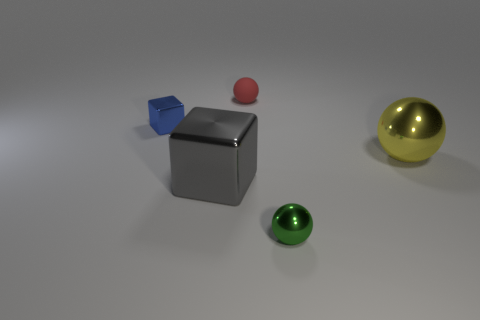Is there anything else that has the same material as the red sphere?
Ensure brevity in your answer.  No. Is the size of the gray metallic block the same as the metal sphere behind the large metal block?
Your answer should be very brief. Yes. How many yellow things have the same size as the gray object?
Ensure brevity in your answer.  1. There is a tiny sphere that is the same material as the blue object; what color is it?
Offer a very short reply. Green. Is the number of blue metallic things greater than the number of large gray cylinders?
Your answer should be compact. Yes. Do the tiny red ball and the green ball have the same material?
Offer a terse response. No. The small green thing that is the same material as the big gray block is what shape?
Your answer should be very brief. Sphere. Are there fewer gray cubes than large green objects?
Provide a succinct answer. No. The small object that is to the left of the green ball and in front of the red sphere is made of what material?
Give a very brief answer. Metal. What is the size of the object that is on the right side of the small metallic thing that is on the right side of the metal object that is left of the gray thing?
Keep it short and to the point. Large. 